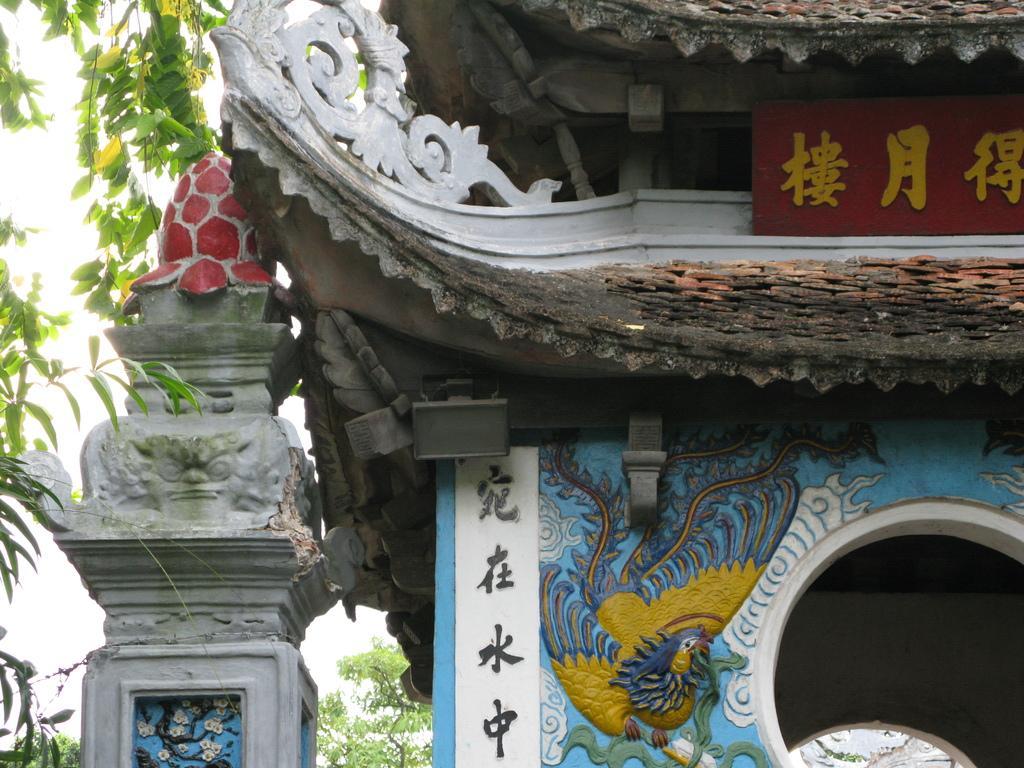How would you summarize this image in a sentence or two? In this picture, it seems like a monument in the foreground area of the image, there are trees and sky in the background. 